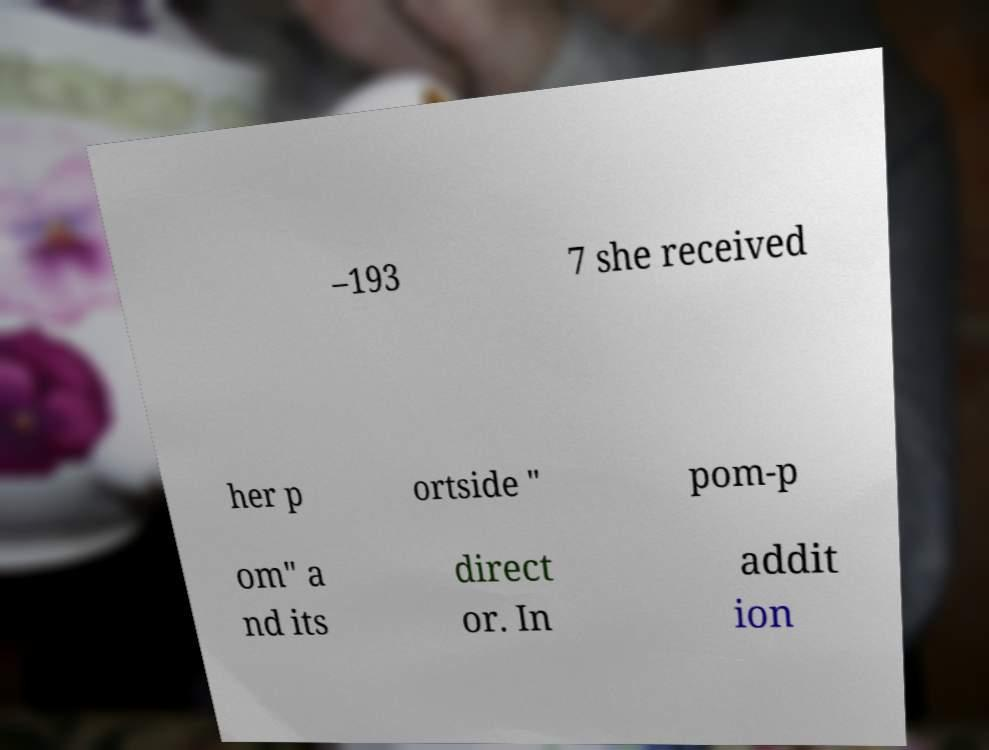Can you accurately transcribe the text from the provided image for me? –193 7 she received her p ortside " pom-p om" a nd its direct or. In addit ion 